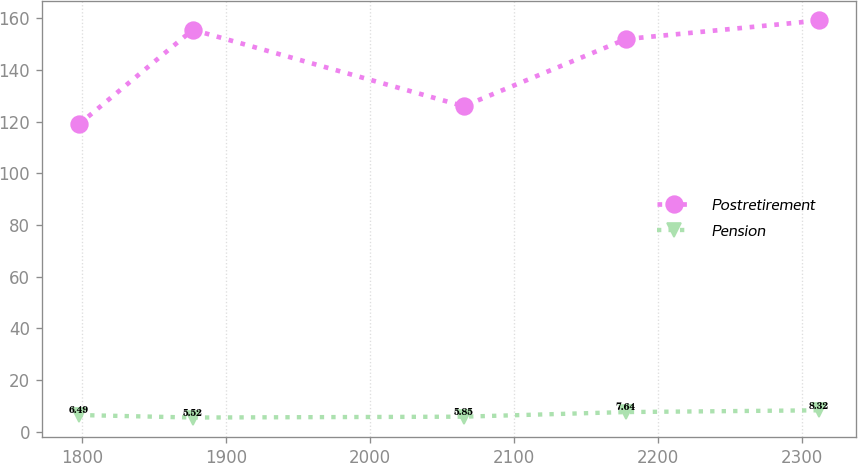<chart> <loc_0><loc_0><loc_500><loc_500><line_chart><ecel><fcel>Postretirement<fcel>Pension<nl><fcel>1797.71<fcel>118.89<fcel>6.49<nl><fcel>1876.97<fcel>155.53<fcel>5.52<nl><fcel>2065.11<fcel>125.96<fcel>5.85<nl><fcel>2177.79<fcel>151.93<fcel>7.64<nl><fcel>2312.02<fcel>159.12<fcel>8.32<nl></chart> 